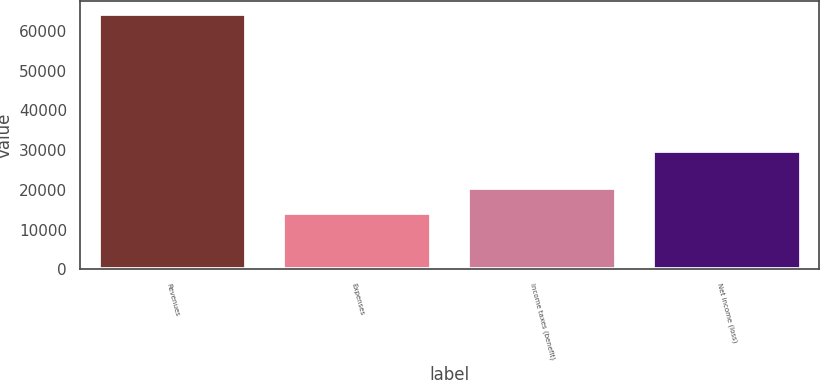<chart> <loc_0><loc_0><loc_500><loc_500><bar_chart><fcel>Revenues<fcel>Expenses<fcel>Income taxes (benefit)<fcel>Net income (loss)<nl><fcel>64239<fcel>14146<fcel>20383<fcel>29710<nl></chart> 